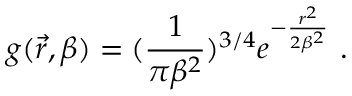Convert formula to latex. <formula><loc_0><loc_0><loc_500><loc_500>g ( \vec { r } , \beta ) = ( \frac { 1 } { \pi \beta ^ { 2 } } ) ^ { 3 / 4 } e ^ { - \frac { r ^ { 2 } } { 2 \beta ^ { 2 } } } \ .</formula> 